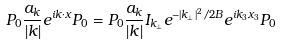<formula> <loc_0><loc_0><loc_500><loc_500>P _ { 0 } \frac { a _ { k } } { | k | } e ^ { i k \cdot x } P _ { 0 } = P _ { 0 } \frac { a _ { k } } { | k | } I _ { k _ { \perp } } e ^ { - | k _ { \perp } | ^ { 2 } / 2 B } e ^ { i k _ { 3 } x _ { 3 } } P _ { 0 }</formula> 